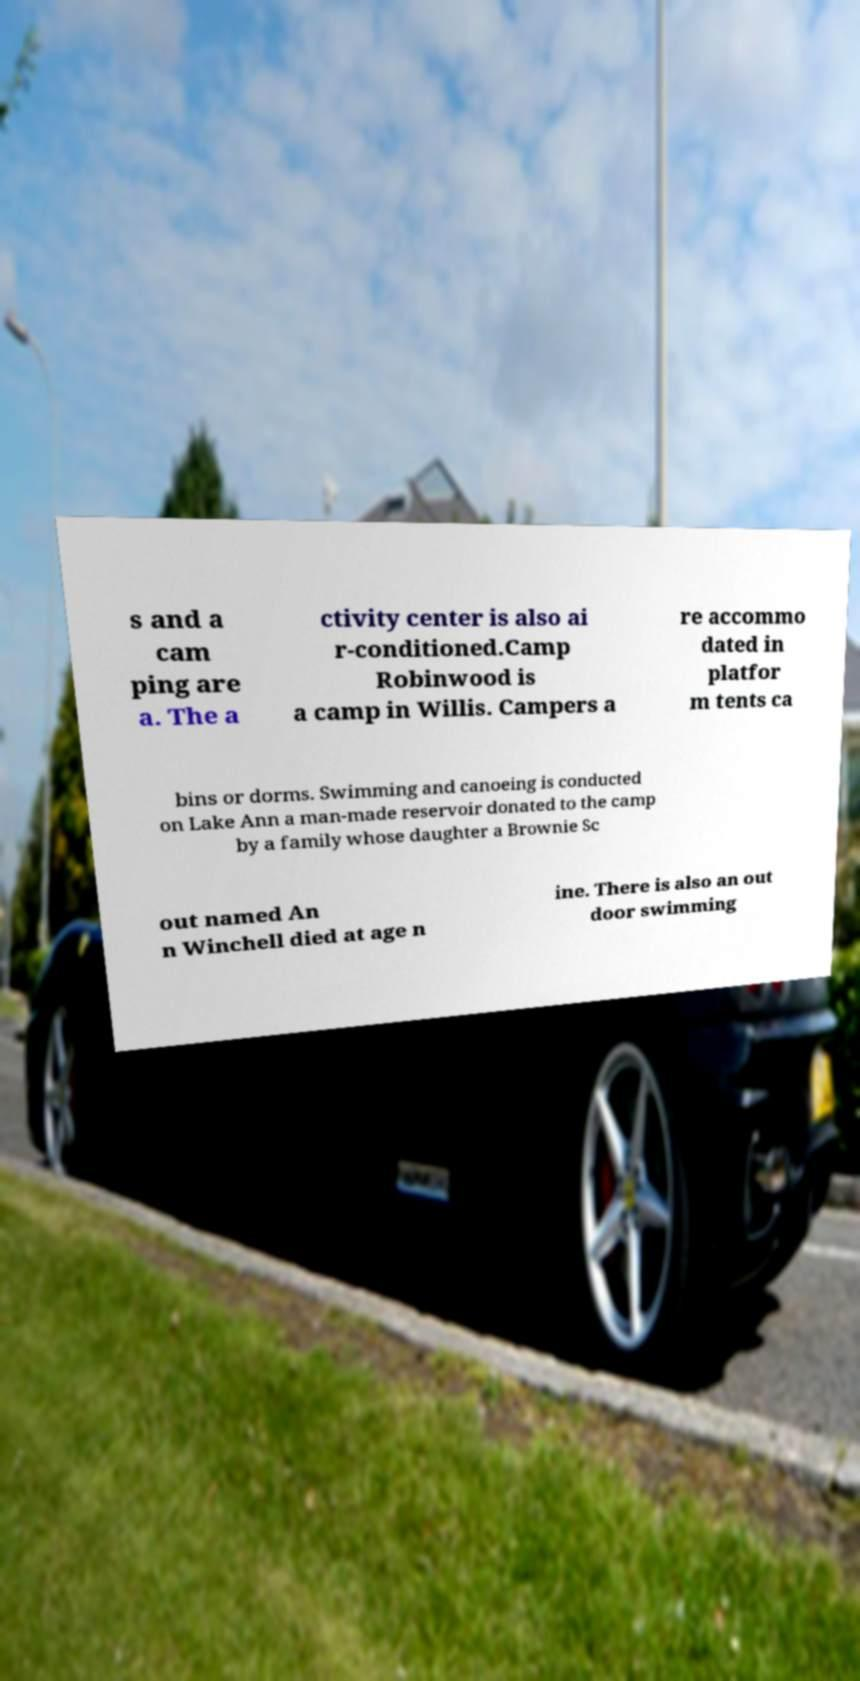There's text embedded in this image that I need extracted. Can you transcribe it verbatim? s and a cam ping are a. The a ctivity center is also ai r-conditioned.Camp Robinwood is a camp in Willis. Campers a re accommo dated in platfor m tents ca bins or dorms. Swimming and canoeing is conducted on Lake Ann a man-made reservoir donated to the camp by a family whose daughter a Brownie Sc out named An n Winchell died at age n ine. There is also an out door swimming 